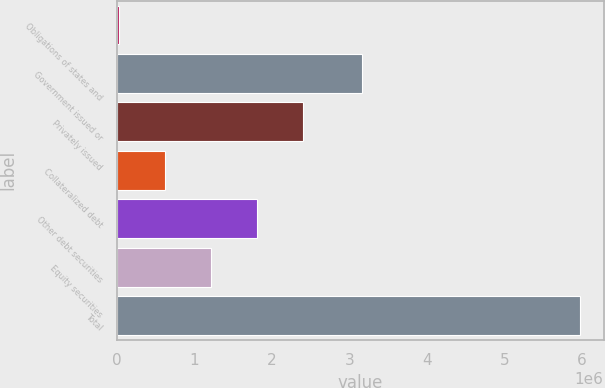<chart> <loc_0><loc_0><loc_500><loc_500><bar_chart><fcel>Obligations of states and<fcel>Government issued or<fcel>Privately issued<fcel>Collateralized debt<fcel>Other debt securities<fcel>Equity securities<fcel>Total<nl><fcel>20375<fcel>3.16321e+06<fcel>2.40342e+06<fcel>616137<fcel>1.80766e+06<fcel>1.2119e+06<fcel>5.97799e+06<nl></chart> 